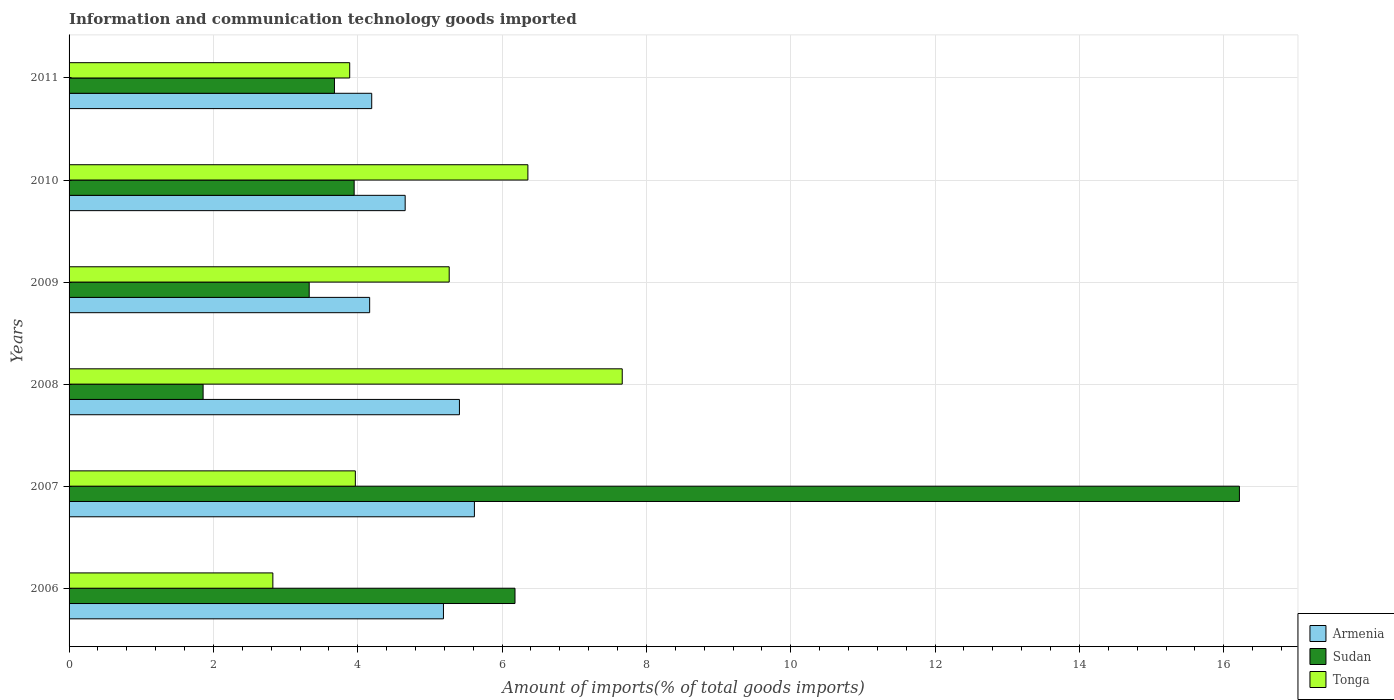In how many cases, is the number of bars for a given year not equal to the number of legend labels?
Provide a short and direct response. 0. What is the amount of goods imported in Sudan in 2007?
Your response must be concise. 16.22. Across all years, what is the maximum amount of goods imported in Tonga?
Make the answer very short. 7.66. Across all years, what is the minimum amount of goods imported in Tonga?
Ensure brevity in your answer.  2.82. In which year was the amount of goods imported in Tonga minimum?
Give a very brief answer. 2006. What is the total amount of goods imported in Tonga in the graph?
Make the answer very short. 29.97. What is the difference between the amount of goods imported in Sudan in 2007 and that in 2011?
Offer a terse response. 12.54. What is the difference between the amount of goods imported in Tonga in 2011 and the amount of goods imported in Sudan in 2007?
Provide a short and direct response. -12.33. What is the average amount of goods imported in Tonga per year?
Give a very brief answer. 4.99. In the year 2009, what is the difference between the amount of goods imported in Armenia and amount of goods imported in Tonga?
Offer a terse response. -1.1. What is the ratio of the amount of goods imported in Tonga in 2007 to that in 2008?
Provide a short and direct response. 0.52. Is the difference between the amount of goods imported in Armenia in 2007 and 2009 greater than the difference between the amount of goods imported in Tonga in 2007 and 2009?
Offer a terse response. Yes. What is the difference between the highest and the second highest amount of goods imported in Sudan?
Your response must be concise. 10.04. What is the difference between the highest and the lowest amount of goods imported in Armenia?
Give a very brief answer. 1.45. What does the 2nd bar from the top in 2007 represents?
Give a very brief answer. Sudan. What does the 1st bar from the bottom in 2011 represents?
Your response must be concise. Armenia. How many bars are there?
Ensure brevity in your answer.  18. Are all the bars in the graph horizontal?
Keep it short and to the point. Yes. How many years are there in the graph?
Your answer should be compact. 6. Are the values on the major ticks of X-axis written in scientific E-notation?
Offer a very short reply. No. How are the legend labels stacked?
Your answer should be very brief. Vertical. What is the title of the graph?
Your answer should be very brief. Information and communication technology goods imported. Does "Thailand" appear as one of the legend labels in the graph?
Give a very brief answer. No. What is the label or title of the X-axis?
Offer a terse response. Amount of imports(% of total goods imports). What is the label or title of the Y-axis?
Your response must be concise. Years. What is the Amount of imports(% of total goods imports) in Armenia in 2006?
Provide a succinct answer. 5.19. What is the Amount of imports(% of total goods imports) in Sudan in 2006?
Make the answer very short. 6.18. What is the Amount of imports(% of total goods imports) in Tonga in 2006?
Offer a terse response. 2.82. What is the Amount of imports(% of total goods imports) in Armenia in 2007?
Offer a very short reply. 5.62. What is the Amount of imports(% of total goods imports) of Sudan in 2007?
Ensure brevity in your answer.  16.22. What is the Amount of imports(% of total goods imports) in Tonga in 2007?
Provide a short and direct response. 3.97. What is the Amount of imports(% of total goods imports) in Armenia in 2008?
Provide a succinct answer. 5.41. What is the Amount of imports(% of total goods imports) of Sudan in 2008?
Provide a succinct answer. 1.86. What is the Amount of imports(% of total goods imports) in Tonga in 2008?
Make the answer very short. 7.66. What is the Amount of imports(% of total goods imports) in Armenia in 2009?
Your answer should be very brief. 4.16. What is the Amount of imports(% of total goods imports) of Sudan in 2009?
Give a very brief answer. 3.33. What is the Amount of imports(% of total goods imports) in Tonga in 2009?
Your response must be concise. 5.27. What is the Amount of imports(% of total goods imports) of Armenia in 2010?
Provide a succinct answer. 4.66. What is the Amount of imports(% of total goods imports) in Sudan in 2010?
Offer a terse response. 3.95. What is the Amount of imports(% of total goods imports) of Tonga in 2010?
Offer a very short reply. 6.36. What is the Amount of imports(% of total goods imports) of Armenia in 2011?
Ensure brevity in your answer.  4.19. What is the Amount of imports(% of total goods imports) in Sudan in 2011?
Your answer should be compact. 3.68. What is the Amount of imports(% of total goods imports) in Tonga in 2011?
Your response must be concise. 3.89. Across all years, what is the maximum Amount of imports(% of total goods imports) in Armenia?
Your response must be concise. 5.62. Across all years, what is the maximum Amount of imports(% of total goods imports) of Sudan?
Offer a terse response. 16.22. Across all years, what is the maximum Amount of imports(% of total goods imports) of Tonga?
Your response must be concise. 7.66. Across all years, what is the minimum Amount of imports(% of total goods imports) in Armenia?
Ensure brevity in your answer.  4.16. Across all years, what is the minimum Amount of imports(% of total goods imports) in Sudan?
Give a very brief answer. 1.86. Across all years, what is the minimum Amount of imports(% of total goods imports) of Tonga?
Provide a short and direct response. 2.82. What is the total Amount of imports(% of total goods imports) in Armenia in the graph?
Offer a terse response. 29.23. What is the total Amount of imports(% of total goods imports) in Sudan in the graph?
Make the answer very short. 35.21. What is the total Amount of imports(% of total goods imports) of Tonga in the graph?
Offer a very short reply. 29.97. What is the difference between the Amount of imports(% of total goods imports) of Armenia in 2006 and that in 2007?
Your answer should be compact. -0.43. What is the difference between the Amount of imports(% of total goods imports) of Sudan in 2006 and that in 2007?
Provide a succinct answer. -10.04. What is the difference between the Amount of imports(% of total goods imports) in Tonga in 2006 and that in 2007?
Give a very brief answer. -1.14. What is the difference between the Amount of imports(% of total goods imports) in Armenia in 2006 and that in 2008?
Your answer should be compact. -0.22. What is the difference between the Amount of imports(% of total goods imports) in Sudan in 2006 and that in 2008?
Provide a succinct answer. 4.32. What is the difference between the Amount of imports(% of total goods imports) in Tonga in 2006 and that in 2008?
Offer a terse response. -4.84. What is the difference between the Amount of imports(% of total goods imports) in Armenia in 2006 and that in 2009?
Provide a short and direct response. 1.02. What is the difference between the Amount of imports(% of total goods imports) of Sudan in 2006 and that in 2009?
Ensure brevity in your answer.  2.85. What is the difference between the Amount of imports(% of total goods imports) of Tonga in 2006 and that in 2009?
Your answer should be very brief. -2.44. What is the difference between the Amount of imports(% of total goods imports) of Armenia in 2006 and that in 2010?
Offer a terse response. 0.53. What is the difference between the Amount of imports(% of total goods imports) in Sudan in 2006 and that in 2010?
Provide a short and direct response. 2.23. What is the difference between the Amount of imports(% of total goods imports) in Tonga in 2006 and that in 2010?
Offer a terse response. -3.53. What is the difference between the Amount of imports(% of total goods imports) of Sudan in 2006 and that in 2011?
Ensure brevity in your answer.  2.5. What is the difference between the Amount of imports(% of total goods imports) of Tonga in 2006 and that in 2011?
Your answer should be compact. -1.06. What is the difference between the Amount of imports(% of total goods imports) of Armenia in 2007 and that in 2008?
Provide a short and direct response. 0.21. What is the difference between the Amount of imports(% of total goods imports) of Sudan in 2007 and that in 2008?
Your response must be concise. 14.36. What is the difference between the Amount of imports(% of total goods imports) of Tonga in 2007 and that in 2008?
Provide a succinct answer. -3.7. What is the difference between the Amount of imports(% of total goods imports) of Armenia in 2007 and that in 2009?
Provide a succinct answer. 1.45. What is the difference between the Amount of imports(% of total goods imports) in Sudan in 2007 and that in 2009?
Provide a short and direct response. 12.89. What is the difference between the Amount of imports(% of total goods imports) in Tonga in 2007 and that in 2009?
Provide a short and direct response. -1.3. What is the difference between the Amount of imports(% of total goods imports) of Armenia in 2007 and that in 2010?
Keep it short and to the point. 0.96. What is the difference between the Amount of imports(% of total goods imports) in Sudan in 2007 and that in 2010?
Offer a very short reply. 12.27. What is the difference between the Amount of imports(% of total goods imports) in Tonga in 2007 and that in 2010?
Provide a succinct answer. -2.39. What is the difference between the Amount of imports(% of total goods imports) in Armenia in 2007 and that in 2011?
Your answer should be compact. 1.42. What is the difference between the Amount of imports(% of total goods imports) of Sudan in 2007 and that in 2011?
Keep it short and to the point. 12.54. What is the difference between the Amount of imports(% of total goods imports) of Tonga in 2007 and that in 2011?
Make the answer very short. 0.08. What is the difference between the Amount of imports(% of total goods imports) in Armenia in 2008 and that in 2009?
Your answer should be compact. 1.24. What is the difference between the Amount of imports(% of total goods imports) of Sudan in 2008 and that in 2009?
Give a very brief answer. -1.47. What is the difference between the Amount of imports(% of total goods imports) of Tonga in 2008 and that in 2009?
Your answer should be very brief. 2.4. What is the difference between the Amount of imports(% of total goods imports) in Armenia in 2008 and that in 2010?
Your answer should be compact. 0.75. What is the difference between the Amount of imports(% of total goods imports) of Sudan in 2008 and that in 2010?
Your answer should be compact. -2.09. What is the difference between the Amount of imports(% of total goods imports) in Tonga in 2008 and that in 2010?
Provide a succinct answer. 1.31. What is the difference between the Amount of imports(% of total goods imports) in Armenia in 2008 and that in 2011?
Keep it short and to the point. 1.22. What is the difference between the Amount of imports(% of total goods imports) in Sudan in 2008 and that in 2011?
Make the answer very short. -1.82. What is the difference between the Amount of imports(% of total goods imports) in Tonga in 2008 and that in 2011?
Offer a very short reply. 3.78. What is the difference between the Amount of imports(% of total goods imports) in Armenia in 2009 and that in 2010?
Your response must be concise. -0.49. What is the difference between the Amount of imports(% of total goods imports) in Sudan in 2009 and that in 2010?
Make the answer very short. -0.62. What is the difference between the Amount of imports(% of total goods imports) of Tonga in 2009 and that in 2010?
Keep it short and to the point. -1.09. What is the difference between the Amount of imports(% of total goods imports) in Armenia in 2009 and that in 2011?
Your answer should be very brief. -0.03. What is the difference between the Amount of imports(% of total goods imports) of Sudan in 2009 and that in 2011?
Your answer should be compact. -0.35. What is the difference between the Amount of imports(% of total goods imports) in Tonga in 2009 and that in 2011?
Your answer should be very brief. 1.38. What is the difference between the Amount of imports(% of total goods imports) of Armenia in 2010 and that in 2011?
Offer a terse response. 0.46. What is the difference between the Amount of imports(% of total goods imports) of Sudan in 2010 and that in 2011?
Offer a terse response. 0.27. What is the difference between the Amount of imports(% of total goods imports) in Tonga in 2010 and that in 2011?
Give a very brief answer. 2.47. What is the difference between the Amount of imports(% of total goods imports) of Armenia in 2006 and the Amount of imports(% of total goods imports) of Sudan in 2007?
Give a very brief answer. -11.03. What is the difference between the Amount of imports(% of total goods imports) in Armenia in 2006 and the Amount of imports(% of total goods imports) in Tonga in 2007?
Give a very brief answer. 1.22. What is the difference between the Amount of imports(% of total goods imports) in Sudan in 2006 and the Amount of imports(% of total goods imports) in Tonga in 2007?
Make the answer very short. 2.21. What is the difference between the Amount of imports(% of total goods imports) of Armenia in 2006 and the Amount of imports(% of total goods imports) of Sudan in 2008?
Offer a terse response. 3.33. What is the difference between the Amount of imports(% of total goods imports) of Armenia in 2006 and the Amount of imports(% of total goods imports) of Tonga in 2008?
Give a very brief answer. -2.48. What is the difference between the Amount of imports(% of total goods imports) of Sudan in 2006 and the Amount of imports(% of total goods imports) of Tonga in 2008?
Offer a very short reply. -1.49. What is the difference between the Amount of imports(% of total goods imports) in Armenia in 2006 and the Amount of imports(% of total goods imports) in Sudan in 2009?
Your answer should be compact. 1.86. What is the difference between the Amount of imports(% of total goods imports) of Armenia in 2006 and the Amount of imports(% of total goods imports) of Tonga in 2009?
Your answer should be compact. -0.08. What is the difference between the Amount of imports(% of total goods imports) of Sudan in 2006 and the Amount of imports(% of total goods imports) of Tonga in 2009?
Keep it short and to the point. 0.91. What is the difference between the Amount of imports(% of total goods imports) of Armenia in 2006 and the Amount of imports(% of total goods imports) of Sudan in 2010?
Provide a succinct answer. 1.24. What is the difference between the Amount of imports(% of total goods imports) in Armenia in 2006 and the Amount of imports(% of total goods imports) in Tonga in 2010?
Your answer should be compact. -1.17. What is the difference between the Amount of imports(% of total goods imports) of Sudan in 2006 and the Amount of imports(% of total goods imports) of Tonga in 2010?
Make the answer very short. -0.18. What is the difference between the Amount of imports(% of total goods imports) of Armenia in 2006 and the Amount of imports(% of total goods imports) of Sudan in 2011?
Your answer should be compact. 1.51. What is the difference between the Amount of imports(% of total goods imports) of Armenia in 2006 and the Amount of imports(% of total goods imports) of Tonga in 2011?
Keep it short and to the point. 1.3. What is the difference between the Amount of imports(% of total goods imports) of Sudan in 2006 and the Amount of imports(% of total goods imports) of Tonga in 2011?
Your answer should be compact. 2.29. What is the difference between the Amount of imports(% of total goods imports) of Armenia in 2007 and the Amount of imports(% of total goods imports) of Sudan in 2008?
Make the answer very short. 3.76. What is the difference between the Amount of imports(% of total goods imports) of Armenia in 2007 and the Amount of imports(% of total goods imports) of Tonga in 2008?
Make the answer very short. -2.05. What is the difference between the Amount of imports(% of total goods imports) of Sudan in 2007 and the Amount of imports(% of total goods imports) of Tonga in 2008?
Ensure brevity in your answer.  8.55. What is the difference between the Amount of imports(% of total goods imports) in Armenia in 2007 and the Amount of imports(% of total goods imports) in Sudan in 2009?
Your answer should be very brief. 2.29. What is the difference between the Amount of imports(% of total goods imports) of Armenia in 2007 and the Amount of imports(% of total goods imports) of Tonga in 2009?
Ensure brevity in your answer.  0.35. What is the difference between the Amount of imports(% of total goods imports) in Sudan in 2007 and the Amount of imports(% of total goods imports) in Tonga in 2009?
Your answer should be very brief. 10.95. What is the difference between the Amount of imports(% of total goods imports) in Armenia in 2007 and the Amount of imports(% of total goods imports) in Sudan in 2010?
Provide a short and direct response. 1.67. What is the difference between the Amount of imports(% of total goods imports) in Armenia in 2007 and the Amount of imports(% of total goods imports) in Tonga in 2010?
Your answer should be very brief. -0.74. What is the difference between the Amount of imports(% of total goods imports) of Sudan in 2007 and the Amount of imports(% of total goods imports) of Tonga in 2010?
Keep it short and to the point. 9.86. What is the difference between the Amount of imports(% of total goods imports) in Armenia in 2007 and the Amount of imports(% of total goods imports) in Sudan in 2011?
Your answer should be very brief. 1.94. What is the difference between the Amount of imports(% of total goods imports) of Armenia in 2007 and the Amount of imports(% of total goods imports) of Tonga in 2011?
Make the answer very short. 1.73. What is the difference between the Amount of imports(% of total goods imports) in Sudan in 2007 and the Amount of imports(% of total goods imports) in Tonga in 2011?
Your answer should be compact. 12.33. What is the difference between the Amount of imports(% of total goods imports) of Armenia in 2008 and the Amount of imports(% of total goods imports) of Sudan in 2009?
Your answer should be compact. 2.08. What is the difference between the Amount of imports(% of total goods imports) in Armenia in 2008 and the Amount of imports(% of total goods imports) in Tonga in 2009?
Make the answer very short. 0.14. What is the difference between the Amount of imports(% of total goods imports) in Sudan in 2008 and the Amount of imports(% of total goods imports) in Tonga in 2009?
Ensure brevity in your answer.  -3.41. What is the difference between the Amount of imports(% of total goods imports) in Armenia in 2008 and the Amount of imports(% of total goods imports) in Sudan in 2010?
Provide a succinct answer. 1.46. What is the difference between the Amount of imports(% of total goods imports) of Armenia in 2008 and the Amount of imports(% of total goods imports) of Tonga in 2010?
Make the answer very short. -0.95. What is the difference between the Amount of imports(% of total goods imports) in Sudan in 2008 and the Amount of imports(% of total goods imports) in Tonga in 2010?
Your answer should be compact. -4.5. What is the difference between the Amount of imports(% of total goods imports) in Armenia in 2008 and the Amount of imports(% of total goods imports) in Sudan in 2011?
Your answer should be compact. 1.73. What is the difference between the Amount of imports(% of total goods imports) of Armenia in 2008 and the Amount of imports(% of total goods imports) of Tonga in 2011?
Your answer should be very brief. 1.52. What is the difference between the Amount of imports(% of total goods imports) of Sudan in 2008 and the Amount of imports(% of total goods imports) of Tonga in 2011?
Provide a short and direct response. -2.03. What is the difference between the Amount of imports(% of total goods imports) in Armenia in 2009 and the Amount of imports(% of total goods imports) in Sudan in 2010?
Offer a very short reply. 0.21. What is the difference between the Amount of imports(% of total goods imports) in Armenia in 2009 and the Amount of imports(% of total goods imports) in Tonga in 2010?
Offer a very short reply. -2.19. What is the difference between the Amount of imports(% of total goods imports) of Sudan in 2009 and the Amount of imports(% of total goods imports) of Tonga in 2010?
Make the answer very short. -3.03. What is the difference between the Amount of imports(% of total goods imports) of Armenia in 2009 and the Amount of imports(% of total goods imports) of Sudan in 2011?
Ensure brevity in your answer.  0.49. What is the difference between the Amount of imports(% of total goods imports) in Armenia in 2009 and the Amount of imports(% of total goods imports) in Tonga in 2011?
Provide a succinct answer. 0.28. What is the difference between the Amount of imports(% of total goods imports) in Sudan in 2009 and the Amount of imports(% of total goods imports) in Tonga in 2011?
Keep it short and to the point. -0.56. What is the difference between the Amount of imports(% of total goods imports) in Armenia in 2010 and the Amount of imports(% of total goods imports) in Sudan in 2011?
Offer a terse response. 0.98. What is the difference between the Amount of imports(% of total goods imports) in Armenia in 2010 and the Amount of imports(% of total goods imports) in Tonga in 2011?
Provide a short and direct response. 0.77. What is the difference between the Amount of imports(% of total goods imports) in Sudan in 2010 and the Amount of imports(% of total goods imports) in Tonga in 2011?
Provide a short and direct response. 0.06. What is the average Amount of imports(% of total goods imports) in Armenia per year?
Give a very brief answer. 4.87. What is the average Amount of imports(% of total goods imports) of Sudan per year?
Keep it short and to the point. 5.87. What is the average Amount of imports(% of total goods imports) in Tonga per year?
Give a very brief answer. 4.99. In the year 2006, what is the difference between the Amount of imports(% of total goods imports) of Armenia and Amount of imports(% of total goods imports) of Sudan?
Your answer should be compact. -0.99. In the year 2006, what is the difference between the Amount of imports(% of total goods imports) in Armenia and Amount of imports(% of total goods imports) in Tonga?
Offer a terse response. 2.36. In the year 2006, what is the difference between the Amount of imports(% of total goods imports) of Sudan and Amount of imports(% of total goods imports) of Tonga?
Offer a terse response. 3.36. In the year 2007, what is the difference between the Amount of imports(% of total goods imports) in Armenia and Amount of imports(% of total goods imports) in Sudan?
Your answer should be very brief. -10.6. In the year 2007, what is the difference between the Amount of imports(% of total goods imports) in Armenia and Amount of imports(% of total goods imports) in Tonga?
Your answer should be compact. 1.65. In the year 2007, what is the difference between the Amount of imports(% of total goods imports) of Sudan and Amount of imports(% of total goods imports) of Tonga?
Ensure brevity in your answer.  12.25. In the year 2008, what is the difference between the Amount of imports(% of total goods imports) of Armenia and Amount of imports(% of total goods imports) of Sudan?
Your response must be concise. 3.55. In the year 2008, what is the difference between the Amount of imports(% of total goods imports) of Armenia and Amount of imports(% of total goods imports) of Tonga?
Make the answer very short. -2.26. In the year 2008, what is the difference between the Amount of imports(% of total goods imports) in Sudan and Amount of imports(% of total goods imports) in Tonga?
Your answer should be very brief. -5.81. In the year 2009, what is the difference between the Amount of imports(% of total goods imports) of Armenia and Amount of imports(% of total goods imports) of Sudan?
Make the answer very short. 0.84. In the year 2009, what is the difference between the Amount of imports(% of total goods imports) of Armenia and Amount of imports(% of total goods imports) of Tonga?
Provide a succinct answer. -1.1. In the year 2009, what is the difference between the Amount of imports(% of total goods imports) in Sudan and Amount of imports(% of total goods imports) in Tonga?
Give a very brief answer. -1.94. In the year 2010, what is the difference between the Amount of imports(% of total goods imports) of Armenia and Amount of imports(% of total goods imports) of Sudan?
Provide a succinct answer. 0.71. In the year 2010, what is the difference between the Amount of imports(% of total goods imports) in Armenia and Amount of imports(% of total goods imports) in Tonga?
Provide a succinct answer. -1.7. In the year 2010, what is the difference between the Amount of imports(% of total goods imports) of Sudan and Amount of imports(% of total goods imports) of Tonga?
Keep it short and to the point. -2.41. In the year 2011, what is the difference between the Amount of imports(% of total goods imports) in Armenia and Amount of imports(% of total goods imports) in Sudan?
Make the answer very short. 0.52. In the year 2011, what is the difference between the Amount of imports(% of total goods imports) in Armenia and Amount of imports(% of total goods imports) in Tonga?
Provide a short and direct response. 0.3. In the year 2011, what is the difference between the Amount of imports(% of total goods imports) of Sudan and Amount of imports(% of total goods imports) of Tonga?
Your answer should be compact. -0.21. What is the ratio of the Amount of imports(% of total goods imports) in Armenia in 2006 to that in 2007?
Your answer should be very brief. 0.92. What is the ratio of the Amount of imports(% of total goods imports) in Sudan in 2006 to that in 2007?
Give a very brief answer. 0.38. What is the ratio of the Amount of imports(% of total goods imports) of Tonga in 2006 to that in 2007?
Offer a very short reply. 0.71. What is the ratio of the Amount of imports(% of total goods imports) in Sudan in 2006 to that in 2008?
Provide a succinct answer. 3.33. What is the ratio of the Amount of imports(% of total goods imports) of Tonga in 2006 to that in 2008?
Keep it short and to the point. 0.37. What is the ratio of the Amount of imports(% of total goods imports) of Armenia in 2006 to that in 2009?
Your answer should be very brief. 1.25. What is the ratio of the Amount of imports(% of total goods imports) in Sudan in 2006 to that in 2009?
Ensure brevity in your answer.  1.86. What is the ratio of the Amount of imports(% of total goods imports) in Tonga in 2006 to that in 2009?
Provide a succinct answer. 0.54. What is the ratio of the Amount of imports(% of total goods imports) of Armenia in 2006 to that in 2010?
Your answer should be very brief. 1.11. What is the ratio of the Amount of imports(% of total goods imports) in Sudan in 2006 to that in 2010?
Ensure brevity in your answer.  1.56. What is the ratio of the Amount of imports(% of total goods imports) in Tonga in 2006 to that in 2010?
Provide a short and direct response. 0.44. What is the ratio of the Amount of imports(% of total goods imports) of Armenia in 2006 to that in 2011?
Ensure brevity in your answer.  1.24. What is the ratio of the Amount of imports(% of total goods imports) of Sudan in 2006 to that in 2011?
Ensure brevity in your answer.  1.68. What is the ratio of the Amount of imports(% of total goods imports) in Tonga in 2006 to that in 2011?
Make the answer very short. 0.73. What is the ratio of the Amount of imports(% of total goods imports) in Armenia in 2007 to that in 2008?
Offer a very short reply. 1.04. What is the ratio of the Amount of imports(% of total goods imports) of Sudan in 2007 to that in 2008?
Your response must be concise. 8.73. What is the ratio of the Amount of imports(% of total goods imports) in Tonga in 2007 to that in 2008?
Provide a short and direct response. 0.52. What is the ratio of the Amount of imports(% of total goods imports) in Armenia in 2007 to that in 2009?
Offer a terse response. 1.35. What is the ratio of the Amount of imports(% of total goods imports) in Sudan in 2007 to that in 2009?
Your answer should be compact. 4.87. What is the ratio of the Amount of imports(% of total goods imports) of Tonga in 2007 to that in 2009?
Your answer should be compact. 0.75. What is the ratio of the Amount of imports(% of total goods imports) of Armenia in 2007 to that in 2010?
Give a very brief answer. 1.21. What is the ratio of the Amount of imports(% of total goods imports) in Sudan in 2007 to that in 2010?
Ensure brevity in your answer.  4.11. What is the ratio of the Amount of imports(% of total goods imports) of Tonga in 2007 to that in 2010?
Offer a terse response. 0.62. What is the ratio of the Amount of imports(% of total goods imports) in Armenia in 2007 to that in 2011?
Ensure brevity in your answer.  1.34. What is the ratio of the Amount of imports(% of total goods imports) of Sudan in 2007 to that in 2011?
Provide a short and direct response. 4.41. What is the ratio of the Amount of imports(% of total goods imports) of Tonga in 2007 to that in 2011?
Make the answer very short. 1.02. What is the ratio of the Amount of imports(% of total goods imports) in Armenia in 2008 to that in 2009?
Offer a very short reply. 1.3. What is the ratio of the Amount of imports(% of total goods imports) of Sudan in 2008 to that in 2009?
Ensure brevity in your answer.  0.56. What is the ratio of the Amount of imports(% of total goods imports) in Tonga in 2008 to that in 2009?
Provide a short and direct response. 1.46. What is the ratio of the Amount of imports(% of total goods imports) of Armenia in 2008 to that in 2010?
Keep it short and to the point. 1.16. What is the ratio of the Amount of imports(% of total goods imports) of Sudan in 2008 to that in 2010?
Your answer should be very brief. 0.47. What is the ratio of the Amount of imports(% of total goods imports) of Tonga in 2008 to that in 2010?
Your response must be concise. 1.21. What is the ratio of the Amount of imports(% of total goods imports) of Armenia in 2008 to that in 2011?
Your response must be concise. 1.29. What is the ratio of the Amount of imports(% of total goods imports) of Sudan in 2008 to that in 2011?
Ensure brevity in your answer.  0.51. What is the ratio of the Amount of imports(% of total goods imports) in Tonga in 2008 to that in 2011?
Your answer should be very brief. 1.97. What is the ratio of the Amount of imports(% of total goods imports) of Armenia in 2009 to that in 2010?
Your response must be concise. 0.89. What is the ratio of the Amount of imports(% of total goods imports) in Sudan in 2009 to that in 2010?
Give a very brief answer. 0.84. What is the ratio of the Amount of imports(% of total goods imports) of Tonga in 2009 to that in 2010?
Your answer should be very brief. 0.83. What is the ratio of the Amount of imports(% of total goods imports) of Sudan in 2009 to that in 2011?
Provide a short and direct response. 0.9. What is the ratio of the Amount of imports(% of total goods imports) in Tonga in 2009 to that in 2011?
Give a very brief answer. 1.35. What is the ratio of the Amount of imports(% of total goods imports) in Armenia in 2010 to that in 2011?
Your answer should be very brief. 1.11. What is the ratio of the Amount of imports(% of total goods imports) in Sudan in 2010 to that in 2011?
Offer a terse response. 1.07. What is the ratio of the Amount of imports(% of total goods imports) in Tonga in 2010 to that in 2011?
Offer a very short reply. 1.64. What is the difference between the highest and the second highest Amount of imports(% of total goods imports) in Armenia?
Your response must be concise. 0.21. What is the difference between the highest and the second highest Amount of imports(% of total goods imports) in Sudan?
Your response must be concise. 10.04. What is the difference between the highest and the second highest Amount of imports(% of total goods imports) in Tonga?
Offer a very short reply. 1.31. What is the difference between the highest and the lowest Amount of imports(% of total goods imports) of Armenia?
Keep it short and to the point. 1.45. What is the difference between the highest and the lowest Amount of imports(% of total goods imports) in Sudan?
Make the answer very short. 14.36. What is the difference between the highest and the lowest Amount of imports(% of total goods imports) of Tonga?
Your answer should be compact. 4.84. 